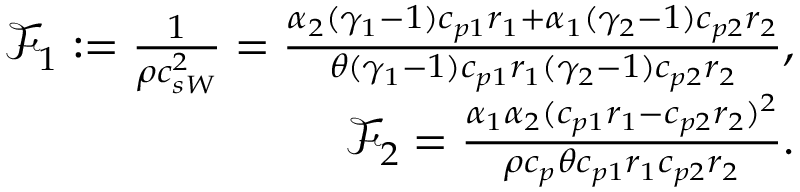<formula> <loc_0><loc_0><loc_500><loc_500>\begin{array} { r } { \mathcal { F } _ { 1 } \colon = \frac { 1 } { \rho c _ { s W } ^ { 2 } } = \frac { \alpha _ { 2 } ( \gamma _ { 1 } - 1 ) c _ { p 1 } r _ { 1 } + \alpha _ { 1 } ( \gamma _ { 2 } - 1 ) c _ { p 2 } r _ { 2 } } { \theta ( \gamma _ { 1 } - 1 ) c _ { p 1 } r _ { 1 } ( \gamma _ { 2 } - 1 ) c _ { p 2 } r _ { 2 } } , } \\ { \mathcal { F } _ { 2 } = \frac { \alpha _ { 1 } \alpha _ { 2 } ( c _ { p 1 } r _ { 1 } - c _ { p 2 } r _ { 2 } ) ^ { 2 } } { \rho c _ { p } \theta c _ { p 1 } r _ { 1 } c _ { p 2 } r _ { 2 } } . } \end{array}</formula> 